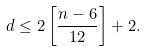Convert formula to latex. <formula><loc_0><loc_0><loc_500><loc_500>d \leq 2 \left [ \frac { n - 6 } { 1 2 } \right ] + 2 .</formula> 